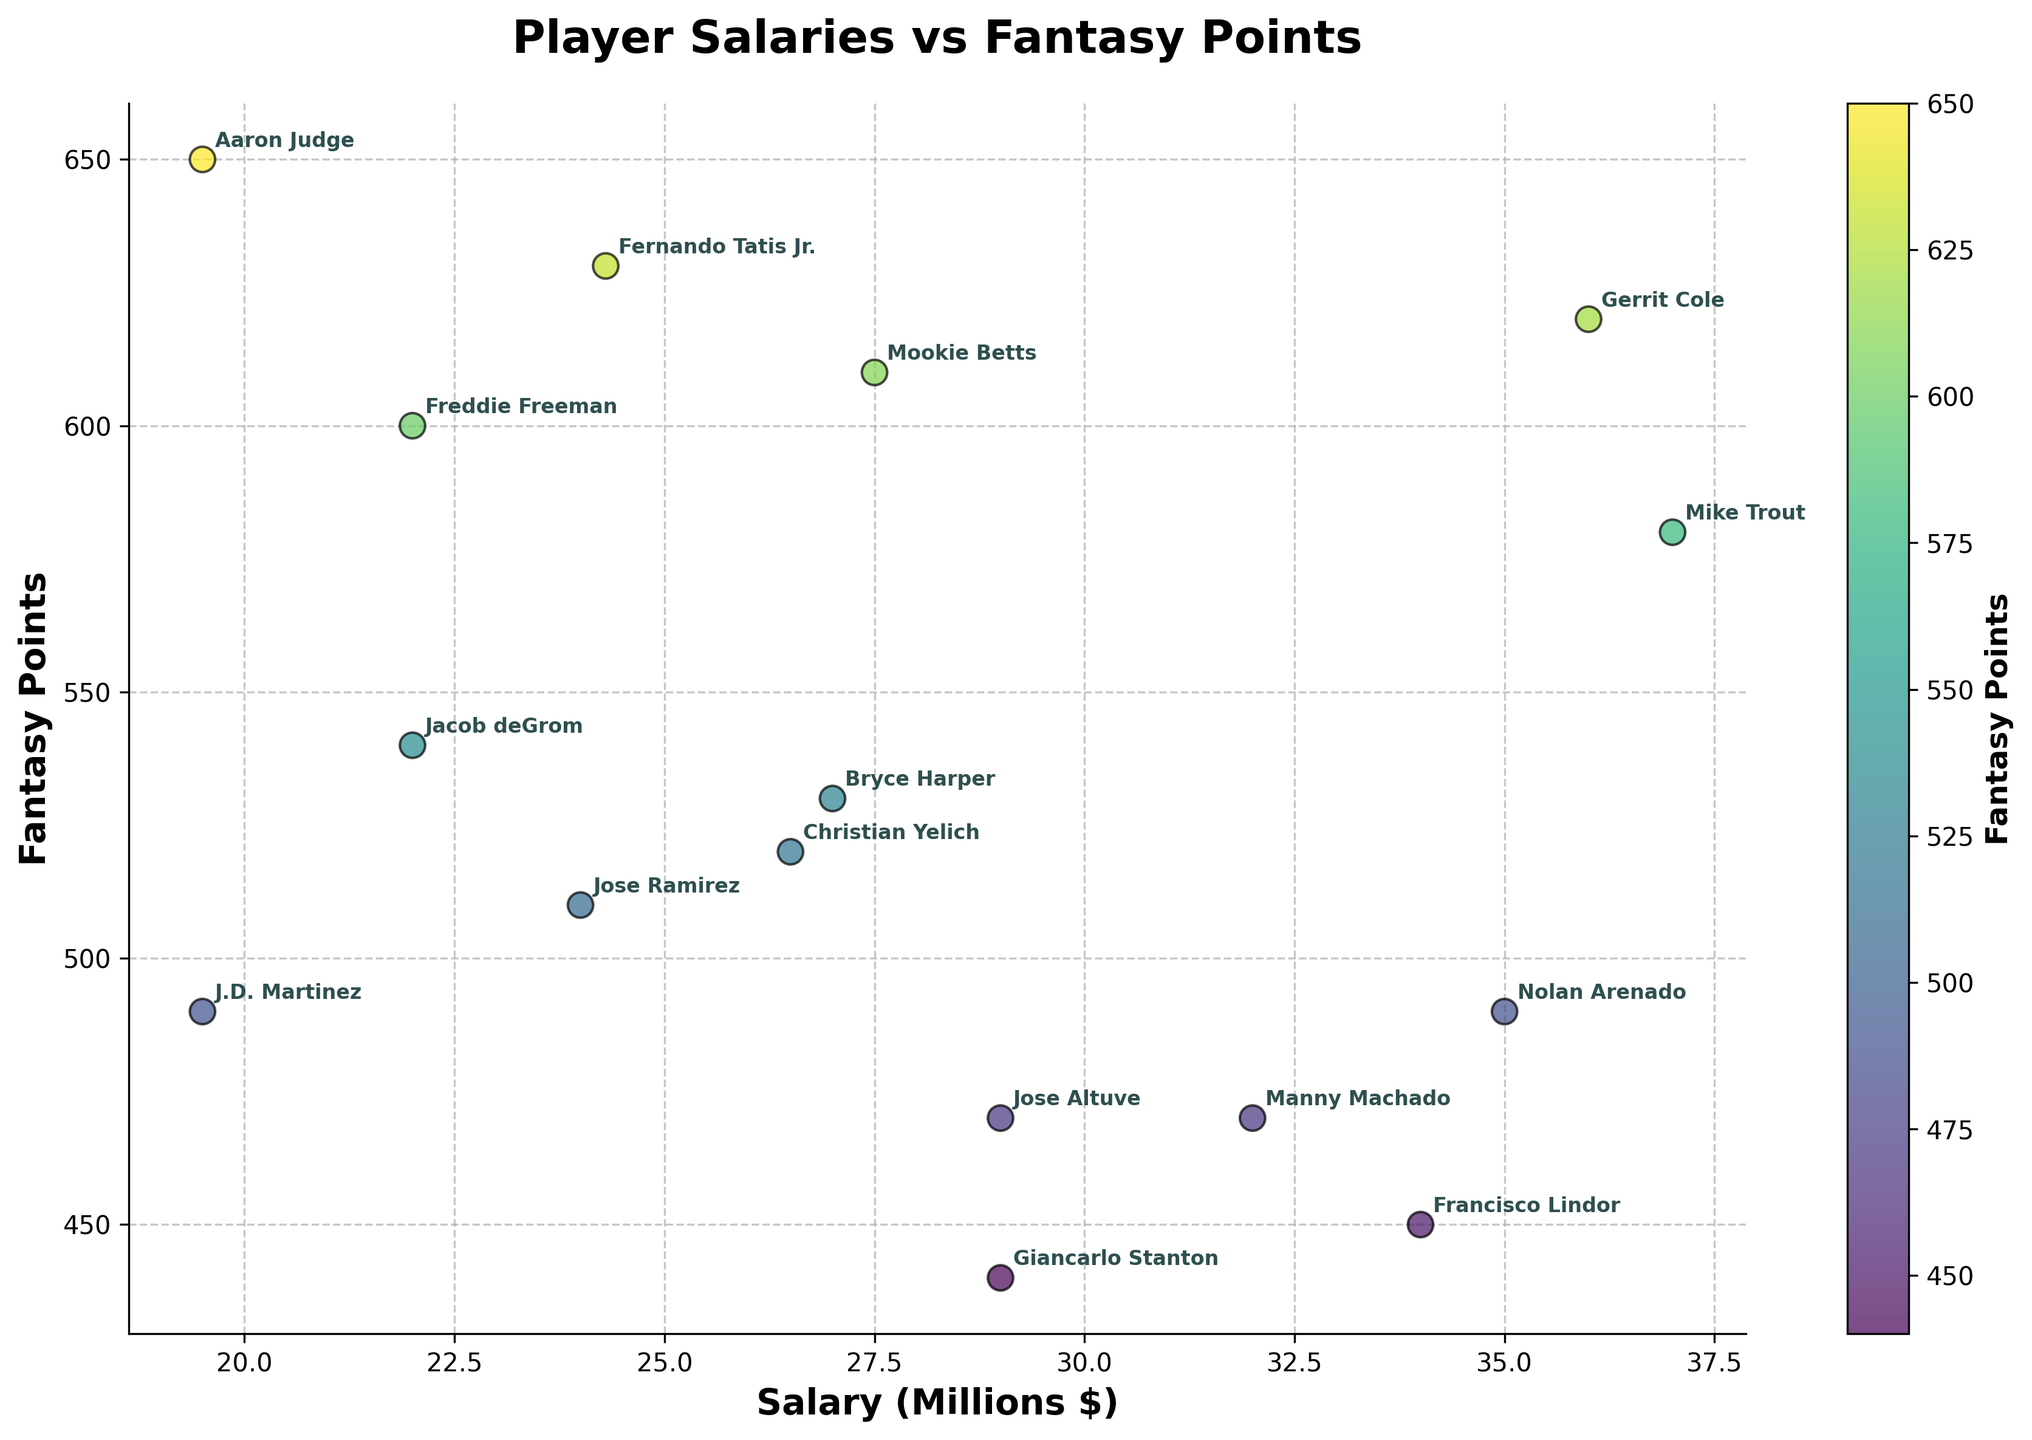Who is the player with the highest fantasy points? Check for the point with the maximum y-value (fantasy points) and identify the player name.
Answer: Aaron Judge What is the title of the plot? Look at the text at the top of the plot.
Answer: Player Salaries vs Fantasy Points How many players have salaries above $30 million? Count the number of data points with x-values (salaries) greater than 30 on the x-axis.
Answer: 5 Which player has the lowest fantasy points but a salary above $30 million? Find the players with x-values above 30, then identify the player with the lowest y-value (fantasy points) among them.
Answer: Francisco Lindor How many players are shown in the plot? Count the total number of data points (players) in the scatter plot.
Answer: 16 Who has a higher salary, Bryce Harper or Gerrit Cole? Compare the x-values (salaries) for Bryce Harper and Gerrit Cole.
Answer: Gerrit Cole Is there a general trend between salaries and fantasy points? Observe the overall direction of the scatter plot points to see if there's a positive, negative, or no clear trend.
Answer: No clear trend Which player with a salary under $20 million has the highest fantasy points? Identify the players with x-values less than 20 and then find the one with the highest y-value (fantasy points).
Answer: Aaron Judge What is the average salary of all players depicted in the plot? Calculate the sum of all salaries and divide by the number of players, Salaries: 37000000 + 27500000 + 22000000 + 32000000 + 27000000 + 19500000 + 35000000 + 22000000 + 36000000 + 24000000 + 34000000 + 24300000 + 29000000 + 26500000 + 29000000 + 19500000 = 444000000, Average Salary: 444000000 / 16
Answer: $27.75 million What color represents higher fantasy points in this plot? Look at the color bar on the side of the plot and identify the colors near the top end.
Answer: Yellow 